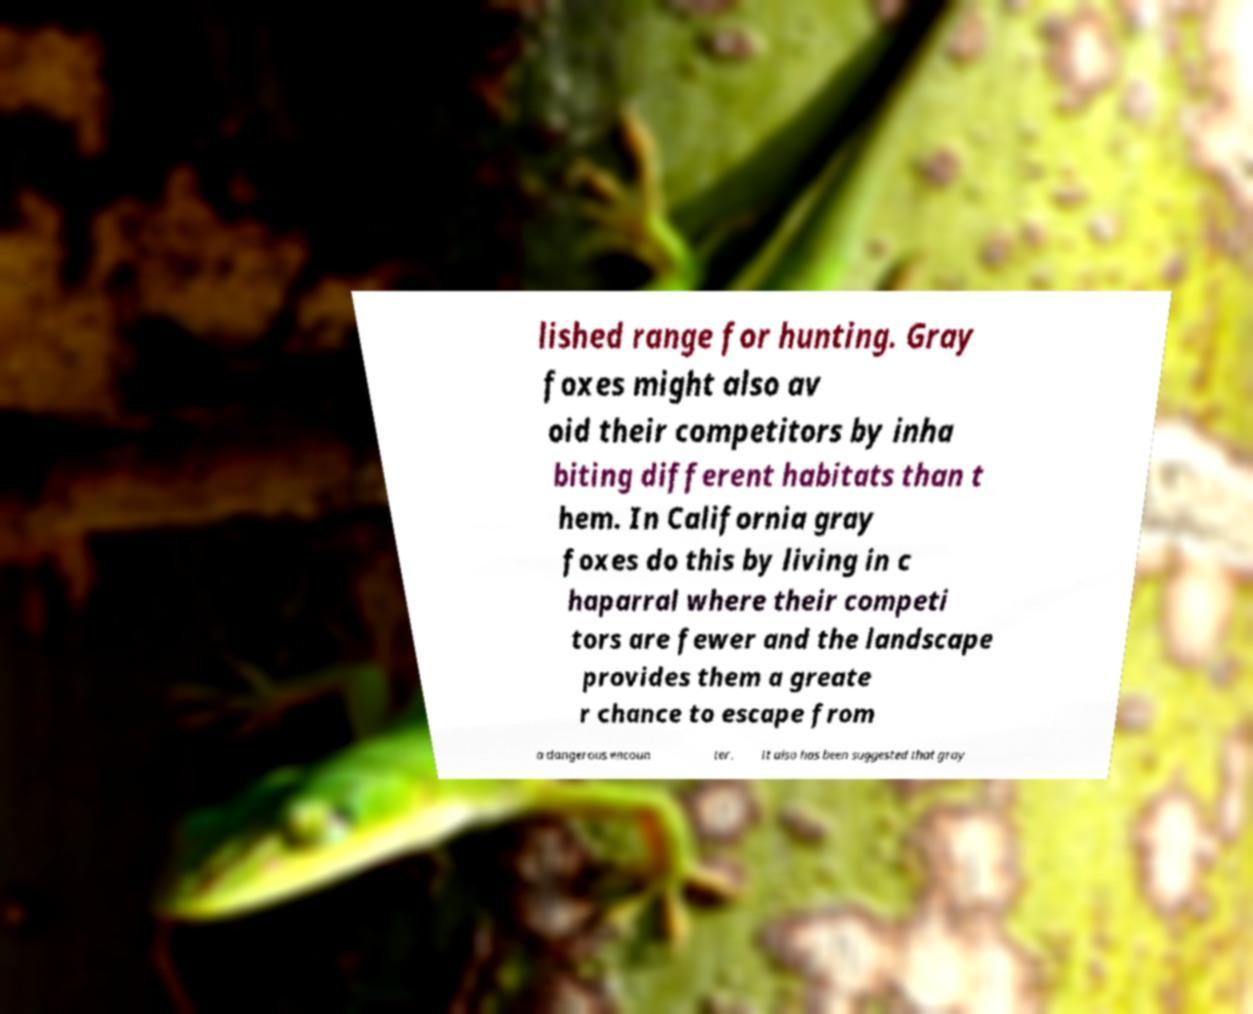Could you extract and type out the text from this image? lished range for hunting. Gray foxes might also av oid their competitors by inha biting different habitats than t hem. In California gray foxes do this by living in c haparral where their competi tors are fewer and the landscape provides them a greate r chance to escape from a dangerous encoun ter. It also has been suggested that gray 